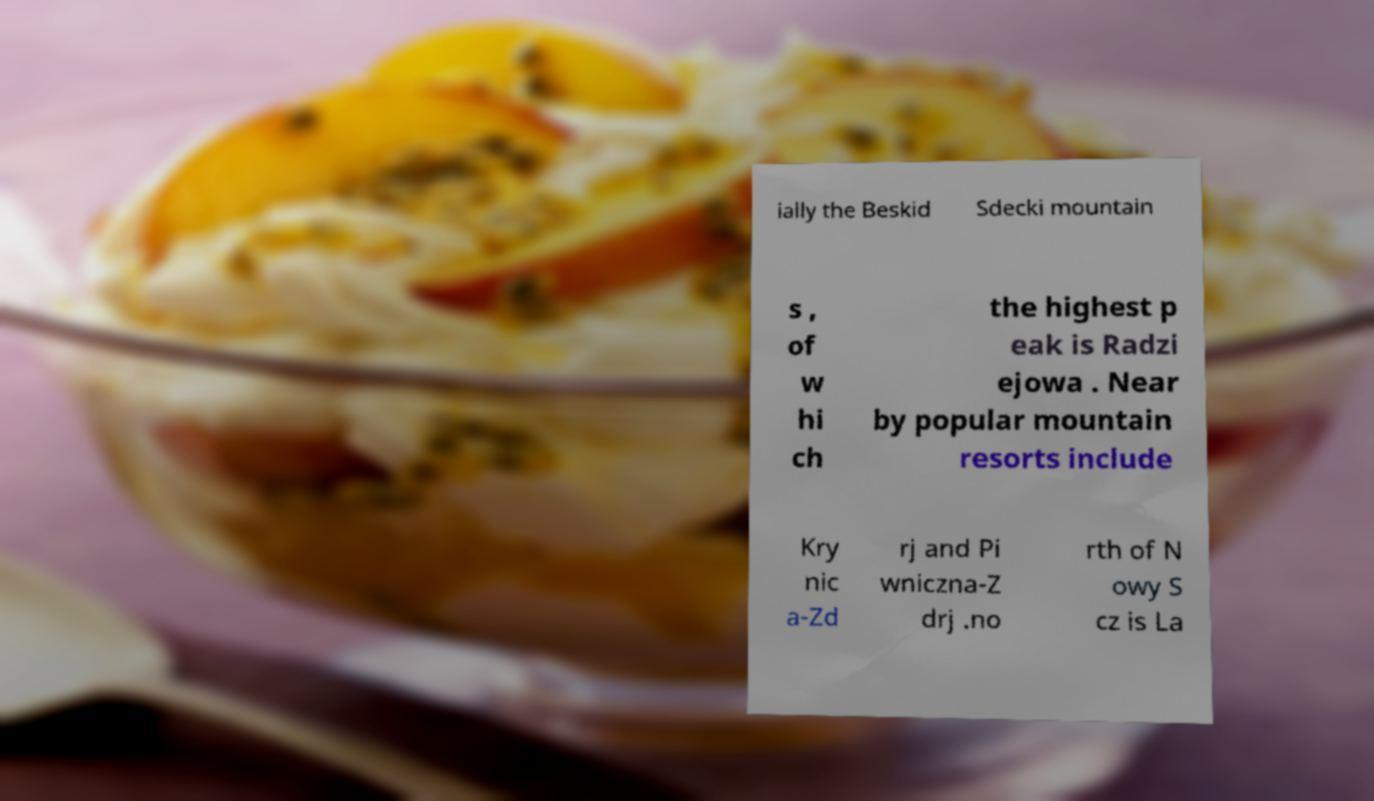There's text embedded in this image that I need extracted. Can you transcribe it verbatim? ially the Beskid Sdecki mountain s , of w hi ch the highest p eak is Radzi ejowa . Near by popular mountain resorts include Kry nic a-Zd rj and Pi wniczna-Z drj .no rth of N owy S cz is La 